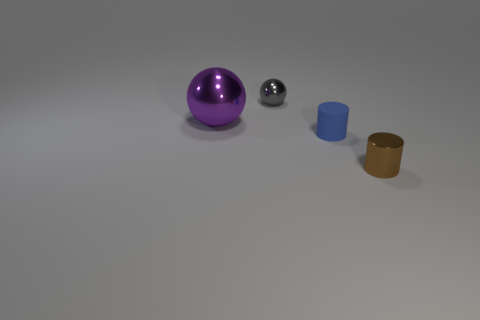Add 2 small gray matte cylinders. How many objects exist? 6 Add 2 small blue objects. How many small blue objects are left? 3 Add 3 matte balls. How many matte balls exist? 3 Subtract 0 gray cylinders. How many objects are left? 4 Subtract all tiny brown objects. Subtract all small metallic spheres. How many objects are left? 2 